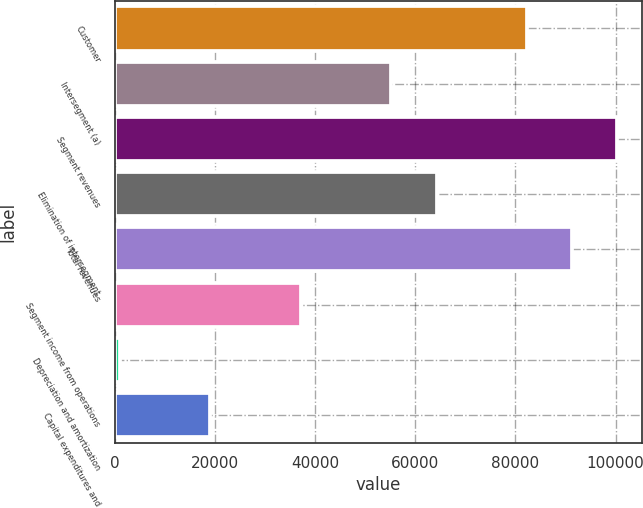<chart> <loc_0><loc_0><loc_500><loc_500><bar_chart><fcel>Customer<fcel>Intersegment (a)<fcel>Segment revenues<fcel>Elimination of intersegment<fcel>Total revenues<fcel>Segment income from operations<fcel>Depreciation and amortization<fcel>Capital expenditures and<nl><fcel>82237<fcel>55236<fcel>100325<fcel>64280<fcel>91281<fcel>37148<fcel>972<fcel>19060<nl></chart> 